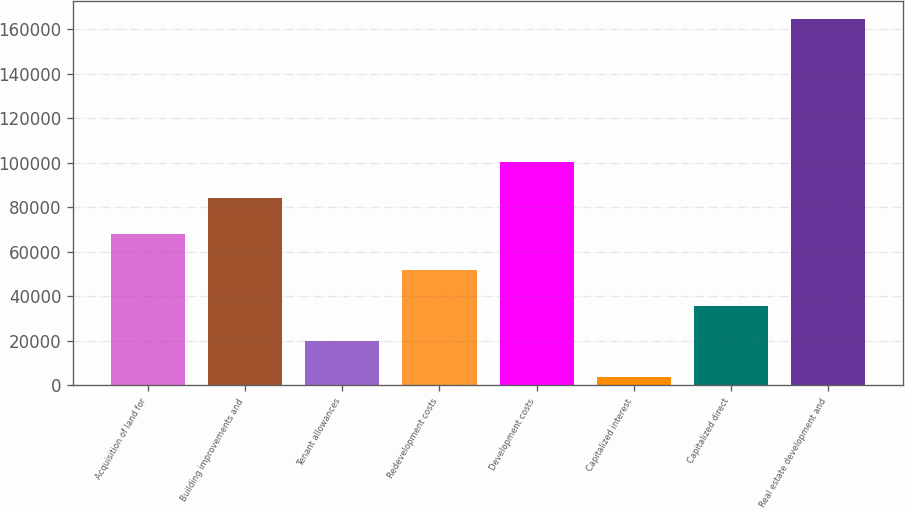Convert chart to OTSL. <chart><loc_0><loc_0><loc_500><loc_500><bar_chart><fcel>Acquisition of land for<fcel>Building improvements and<fcel>Tenant allowances<fcel>Redevelopment costs<fcel>Development costs<fcel>Capitalized interest<fcel>Capitalized direct<fcel>Real estate development and<nl><fcel>68046.8<fcel>84137<fcel>19776.2<fcel>51956.6<fcel>100227<fcel>3686<fcel>35866.4<fcel>164588<nl></chart> 